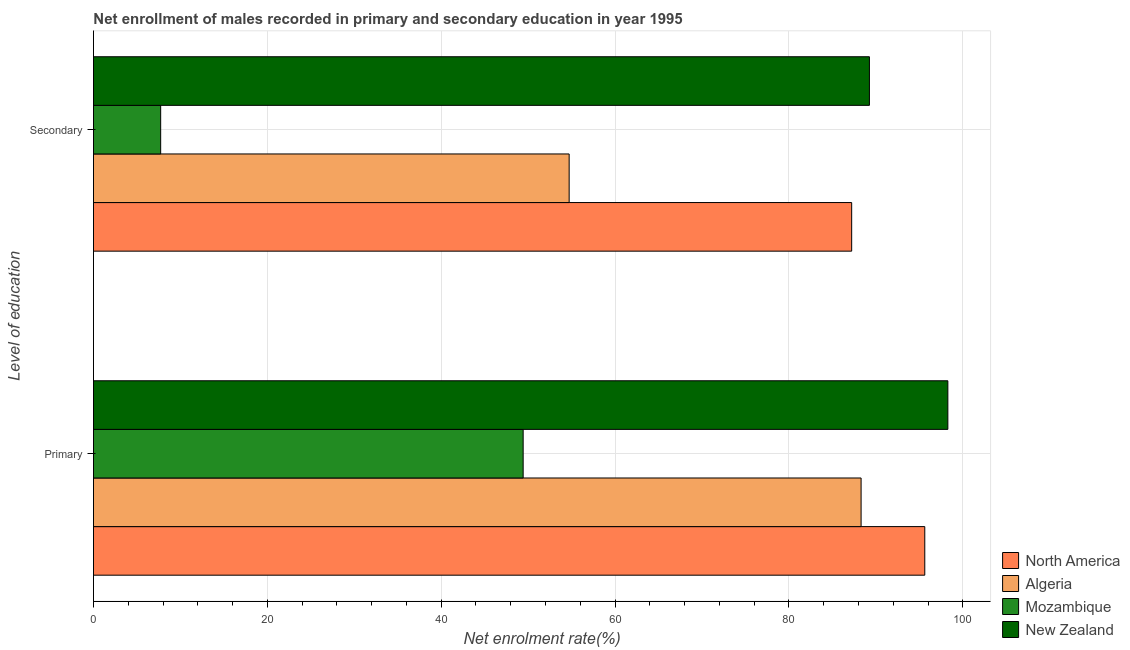How many different coloured bars are there?
Provide a short and direct response. 4. Are the number of bars per tick equal to the number of legend labels?
Give a very brief answer. Yes. Are the number of bars on each tick of the Y-axis equal?
Ensure brevity in your answer.  Yes. How many bars are there on the 2nd tick from the top?
Provide a short and direct response. 4. What is the label of the 2nd group of bars from the top?
Provide a succinct answer. Primary. What is the enrollment rate in secondary education in Mozambique?
Your answer should be compact. 7.73. Across all countries, what is the maximum enrollment rate in secondary education?
Your answer should be very brief. 89.26. Across all countries, what is the minimum enrollment rate in primary education?
Your response must be concise. 49.43. In which country was the enrollment rate in primary education maximum?
Provide a short and direct response. New Zealand. In which country was the enrollment rate in primary education minimum?
Your answer should be very brief. Mozambique. What is the total enrollment rate in secondary education in the graph?
Make the answer very short. 238.93. What is the difference between the enrollment rate in primary education in Algeria and that in North America?
Keep it short and to the point. -7.33. What is the difference between the enrollment rate in secondary education in Mozambique and the enrollment rate in primary education in Algeria?
Ensure brevity in your answer.  -80.57. What is the average enrollment rate in primary education per country?
Offer a terse response. 82.91. What is the difference between the enrollment rate in secondary education and enrollment rate in primary education in Algeria?
Make the answer very short. -33.58. In how many countries, is the enrollment rate in secondary education greater than 56 %?
Make the answer very short. 2. What is the ratio of the enrollment rate in primary education in Mozambique to that in Algeria?
Provide a succinct answer. 0.56. Is the enrollment rate in secondary education in New Zealand less than that in Algeria?
Ensure brevity in your answer.  No. What does the 1st bar from the top in Primary represents?
Make the answer very short. New Zealand. What does the 1st bar from the bottom in Secondary represents?
Your answer should be compact. North America. Are all the bars in the graph horizontal?
Give a very brief answer. Yes. How many countries are there in the graph?
Ensure brevity in your answer.  4. What is the difference between two consecutive major ticks on the X-axis?
Your response must be concise. 20. Are the values on the major ticks of X-axis written in scientific E-notation?
Give a very brief answer. No. Does the graph contain any zero values?
Make the answer very short. No. What is the title of the graph?
Give a very brief answer. Net enrollment of males recorded in primary and secondary education in year 1995. What is the label or title of the X-axis?
Offer a terse response. Net enrolment rate(%). What is the label or title of the Y-axis?
Offer a terse response. Level of education. What is the Net enrolment rate(%) of North America in Primary?
Ensure brevity in your answer.  95.63. What is the Net enrolment rate(%) of Algeria in Primary?
Offer a terse response. 88.3. What is the Net enrolment rate(%) of Mozambique in Primary?
Your answer should be compact. 49.43. What is the Net enrolment rate(%) in New Zealand in Primary?
Make the answer very short. 98.28. What is the Net enrolment rate(%) of North America in Secondary?
Your answer should be compact. 87.22. What is the Net enrolment rate(%) of Algeria in Secondary?
Offer a very short reply. 54.72. What is the Net enrolment rate(%) in Mozambique in Secondary?
Provide a short and direct response. 7.73. What is the Net enrolment rate(%) in New Zealand in Secondary?
Offer a terse response. 89.26. Across all Level of education, what is the maximum Net enrolment rate(%) in North America?
Ensure brevity in your answer.  95.63. Across all Level of education, what is the maximum Net enrolment rate(%) in Algeria?
Make the answer very short. 88.3. Across all Level of education, what is the maximum Net enrolment rate(%) of Mozambique?
Your answer should be compact. 49.43. Across all Level of education, what is the maximum Net enrolment rate(%) of New Zealand?
Offer a very short reply. 98.28. Across all Level of education, what is the minimum Net enrolment rate(%) of North America?
Your answer should be compact. 87.22. Across all Level of education, what is the minimum Net enrolment rate(%) in Algeria?
Make the answer very short. 54.72. Across all Level of education, what is the minimum Net enrolment rate(%) of Mozambique?
Keep it short and to the point. 7.73. Across all Level of education, what is the minimum Net enrolment rate(%) of New Zealand?
Keep it short and to the point. 89.26. What is the total Net enrolment rate(%) in North America in the graph?
Give a very brief answer. 182.85. What is the total Net enrolment rate(%) in Algeria in the graph?
Offer a terse response. 143.02. What is the total Net enrolment rate(%) of Mozambique in the graph?
Your response must be concise. 57.16. What is the total Net enrolment rate(%) of New Zealand in the graph?
Offer a very short reply. 187.54. What is the difference between the Net enrolment rate(%) of North America in Primary and that in Secondary?
Your response must be concise. 8.41. What is the difference between the Net enrolment rate(%) of Algeria in Primary and that in Secondary?
Your answer should be very brief. 33.58. What is the difference between the Net enrolment rate(%) of Mozambique in Primary and that in Secondary?
Your answer should be compact. 41.7. What is the difference between the Net enrolment rate(%) in New Zealand in Primary and that in Secondary?
Give a very brief answer. 9.02. What is the difference between the Net enrolment rate(%) in North America in Primary and the Net enrolment rate(%) in Algeria in Secondary?
Offer a very short reply. 40.91. What is the difference between the Net enrolment rate(%) of North America in Primary and the Net enrolment rate(%) of Mozambique in Secondary?
Offer a very short reply. 87.9. What is the difference between the Net enrolment rate(%) of North America in Primary and the Net enrolment rate(%) of New Zealand in Secondary?
Your answer should be very brief. 6.37. What is the difference between the Net enrolment rate(%) in Algeria in Primary and the Net enrolment rate(%) in Mozambique in Secondary?
Provide a short and direct response. 80.57. What is the difference between the Net enrolment rate(%) of Algeria in Primary and the Net enrolment rate(%) of New Zealand in Secondary?
Your answer should be compact. -0.96. What is the difference between the Net enrolment rate(%) of Mozambique in Primary and the Net enrolment rate(%) of New Zealand in Secondary?
Give a very brief answer. -39.83. What is the average Net enrolment rate(%) of North America per Level of education?
Make the answer very short. 91.42. What is the average Net enrolment rate(%) of Algeria per Level of education?
Offer a terse response. 71.51. What is the average Net enrolment rate(%) in Mozambique per Level of education?
Your answer should be compact. 28.58. What is the average Net enrolment rate(%) in New Zealand per Level of education?
Ensure brevity in your answer.  93.77. What is the difference between the Net enrolment rate(%) of North America and Net enrolment rate(%) of Algeria in Primary?
Offer a very short reply. 7.33. What is the difference between the Net enrolment rate(%) in North America and Net enrolment rate(%) in Mozambique in Primary?
Offer a terse response. 46.2. What is the difference between the Net enrolment rate(%) in North America and Net enrolment rate(%) in New Zealand in Primary?
Your answer should be very brief. -2.66. What is the difference between the Net enrolment rate(%) of Algeria and Net enrolment rate(%) of Mozambique in Primary?
Give a very brief answer. 38.87. What is the difference between the Net enrolment rate(%) of Algeria and Net enrolment rate(%) of New Zealand in Primary?
Offer a very short reply. -9.98. What is the difference between the Net enrolment rate(%) of Mozambique and Net enrolment rate(%) of New Zealand in Primary?
Your response must be concise. -48.86. What is the difference between the Net enrolment rate(%) in North America and Net enrolment rate(%) in Algeria in Secondary?
Keep it short and to the point. 32.5. What is the difference between the Net enrolment rate(%) of North America and Net enrolment rate(%) of Mozambique in Secondary?
Provide a short and direct response. 79.49. What is the difference between the Net enrolment rate(%) in North America and Net enrolment rate(%) in New Zealand in Secondary?
Keep it short and to the point. -2.04. What is the difference between the Net enrolment rate(%) of Algeria and Net enrolment rate(%) of Mozambique in Secondary?
Your response must be concise. 46.99. What is the difference between the Net enrolment rate(%) in Algeria and Net enrolment rate(%) in New Zealand in Secondary?
Provide a succinct answer. -34.54. What is the difference between the Net enrolment rate(%) of Mozambique and Net enrolment rate(%) of New Zealand in Secondary?
Give a very brief answer. -81.53. What is the ratio of the Net enrolment rate(%) in North America in Primary to that in Secondary?
Ensure brevity in your answer.  1.1. What is the ratio of the Net enrolment rate(%) in Algeria in Primary to that in Secondary?
Give a very brief answer. 1.61. What is the ratio of the Net enrolment rate(%) in Mozambique in Primary to that in Secondary?
Make the answer very short. 6.39. What is the ratio of the Net enrolment rate(%) of New Zealand in Primary to that in Secondary?
Provide a succinct answer. 1.1. What is the difference between the highest and the second highest Net enrolment rate(%) of North America?
Give a very brief answer. 8.41. What is the difference between the highest and the second highest Net enrolment rate(%) of Algeria?
Make the answer very short. 33.58. What is the difference between the highest and the second highest Net enrolment rate(%) of Mozambique?
Offer a terse response. 41.7. What is the difference between the highest and the second highest Net enrolment rate(%) of New Zealand?
Keep it short and to the point. 9.02. What is the difference between the highest and the lowest Net enrolment rate(%) of North America?
Keep it short and to the point. 8.41. What is the difference between the highest and the lowest Net enrolment rate(%) in Algeria?
Provide a succinct answer. 33.58. What is the difference between the highest and the lowest Net enrolment rate(%) in Mozambique?
Offer a very short reply. 41.7. What is the difference between the highest and the lowest Net enrolment rate(%) in New Zealand?
Ensure brevity in your answer.  9.02. 